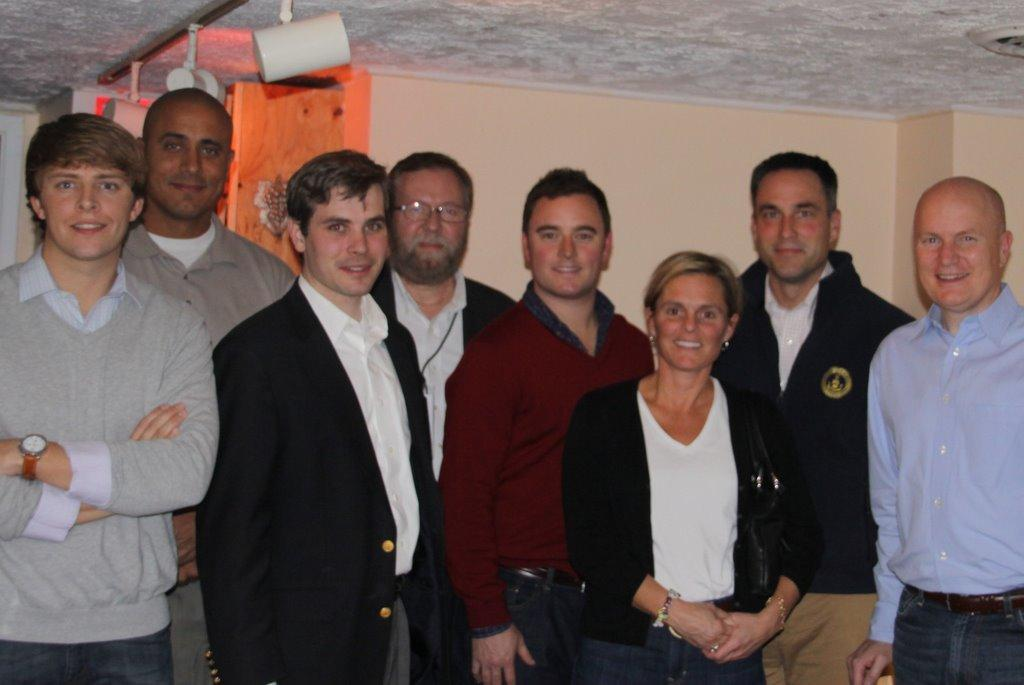What is happening in the image? There are people standing in the image. What can be seen in the background of the image? There are lights visible in the background, as well as a wall and a roof. What time of day is it in the image, based on the hour? The provided facts do not mention a specific time of day or hour, so it cannot be determined from the image. 